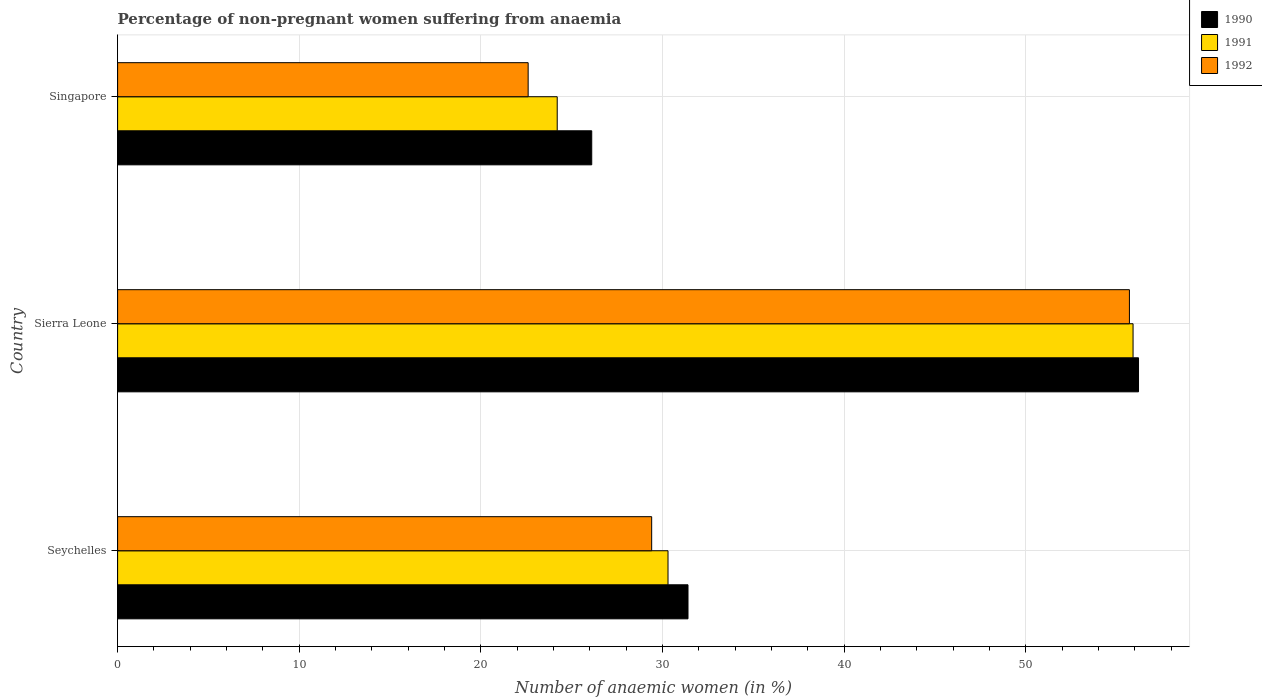How many groups of bars are there?
Offer a very short reply. 3. Are the number of bars per tick equal to the number of legend labels?
Ensure brevity in your answer.  Yes. Are the number of bars on each tick of the Y-axis equal?
Ensure brevity in your answer.  Yes. How many bars are there on the 2nd tick from the top?
Offer a very short reply. 3. How many bars are there on the 2nd tick from the bottom?
Your answer should be compact. 3. What is the label of the 2nd group of bars from the top?
Make the answer very short. Sierra Leone. What is the percentage of non-pregnant women suffering from anaemia in 1992 in Sierra Leone?
Make the answer very short. 55.7. Across all countries, what is the maximum percentage of non-pregnant women suffering from anaemia in 1990?
Your answer should be very brief. 56.2. Across all countries, what is the minimum percentage of non-pregnant women suffering from anaemia in 1991?
Provide a short and direct response. 24.2. In which country was the percentage of non-pregnant women suffering from anaemia in 1991 maximum?
Offer a very short reply. Sierra Leone. In which country was the percentage of non-pregnant women suffering from anaemia in 1990 minimum?
Offer a terse response. Singapore. What is the total percentage of non-pregnant women suffering from anaemia in 1991 in the graph?
Offer a very short reply. 110.4. What is the difference between the percentage of non-pregnant women suffering from anaemia in 1992 in Seychelles and that in Singapore?
Offer a terse response. 6.8. What is the difference between the percentage of non-pregnant women suffering from anaemia in 1990 in Sierra Leone and the percentage of non-pregnant women suffering from anaemia in 1991 in Seychelles?
Make the answer very short. 25.9. What is the average percentage of non-pregnant women suffering from anaemia in 1992 per country?
Ensure brevity in your answer.  35.9. What is the difference between the percentage of non-pregnant women suffering from anaemia in 1990 and percentage of non-pregnant women suffering from anaemia in 1991 in Seychelles?
Make the answer very short. 1.1. In how many countries, is the percentage of non-pregnant women suffering from anaemia in 1992 greater than 10 %?
Your response must be concise. 3. What is the ratio of the percentage of non-pregnant women suffering from anaemia in 1990 in Seychelles to that in Singapore?
Your response must be concise. 1.2. What is the difference between the highest and the second highest percentage of non-pregnant women suffering from anaemia in 1992?
Keep it short and to the point. 26.3. What is the difference between the highest and the lowest percentage of non-pregnant women suffering from anaemia in 1991?
Your response must be concise. 31.7. In how many countries, is the percentage of non-pregnant women suffering from anaemia in 1990 greater than the average percentage of non-pregnant women suffering from anaemia in 1990 taken over all countries?
Make the answer very short. 1. Is the sum of the percentage of non-pregnant women suffering from anaemia in 1990 in Seychelles and Sierra Leone greater than the maximum percentage of non-pregnant women suffering from anaemia in 1991 across all countries?
Ensure brevity in your answer.  Yes. Is it the case that in every country, the sum of the percentage of non-pregnant women suffering from anaemia in 1991 and percentage of non-pregnant women suffering from anaemia in 1992 is greater than the percentage of non-pregnant women suffering from anaemia in 1990?
Ensure brevity in your answer.  Yes. How many bars are there?
Your response must be concise. 9. Does the graph contain any zero values?
Ensure brevity in your answer.  No. Does the graph contain grids?
Offer a very short reply. Yes. What is the title of the graph?
Your answer should be very brief. Percentage of non-pregnant women suffering from anaemia. Does "1988" appear as one of the legend labels in the graph?
Your response must be concise. No. What is the label or title of the X-axis?
Give a very brief answer. Number of anaemic women (in %). What is the label or title of the Y-axis?
Provide a short and direct response. Country. What is the Number of anaemic women (in %) of 1990 in Seychelles?
Offer a terse response. 31.4. What is the Number of anaemic women (in %) in 1991 in Seychelles?
Offer a terse response. 30.3. What is the Number of anaemic women (in %) in 1992 in Seychelles?
Provide a short and direct response. 29.4. What is the Number of anaemic women (in %) in 1990 in Sierra Leone?
Make the answer very short. 56.2. What is the Number of anaemic women (in %) in 1991 in Sierra Leone?
Make the answer very short. 55.9. What is the Number of anaemic women (in %) of 1992 in Sierra Leone?
Offer a terse response. 55.7. What is the Number of anaemic women (in %) of 1990 in Singapore?
Give a very brief answer. 26.1. What is the Number of anaemic women (in %) in 1991 in Singapore?
Your answer should be very brief. 24.2. What is the Number of anaemic women (in %) in 1992 in Singapore?
Provide a succinct answer. 22.6. Across all countries, what is the maximum Number of anaemic women (in %) in 1990?
Your answer should be very brief. 56.2. Across all countries, what is the maximum Number of anaemic women (in %) in 1991?
Your answer should be very brief. 55.9. Across all countries, what is the maximum Number of anaemic women (in %) in 1992?
Offer a terse response. 55.7. Across all countries, what is the minimum Number of anaemic women (in %) of 1990?
Provide a short and direct response. 26.1. Across all countries, what is the minimum Number of anaemic women (in %) of 1991?
Provide a succinct answer. 24.2. Across all countries, what is the minimum Number of anaemic women (in %) in 1992?
Make the answer very short. 22.6. What is the total Number of anaemic women (in %) in 1990 in the graph?
Give a very brief answer. 113.7. What is the total Number of anaemic women (in %) in 1991 in the graph?
Ensure brevity in your answer.  110.4. What is the total Number of anaemic women (in %) in 1992 in the graph?
Keep it short and to the point. 107.7. What is the difference between the Number of anaemic women (in %) of 1990 in Seychelles and that in Sierra Leone?
Your answer should be very brief. -24.8. What is the difference between the Number of anaemic women (in %) of 1991 in Seychelles and that in Sierra Leone?
Offer a very short reply. -25.6. What is the difference between the Number of anaemic women (in %) of 1992 in Seychelles and that in Sierra Leone?
Provide a succinct answer. -26.3. What is the difference between the Number of anaemic women (in %) in 1990 in Seychelles and that in Singapore?
Provide a succinct answer. 5.3. What is the difference between the Number of anaemic women (in %) in 1990 in Sierra Leone and that in Singapore?
Your answer should be very brief. 30.1. What is the difference between the Number of anaemic women (in %) of 1991 in Sierra Leone and that in Singapore?
Ensure brevity in your answer.  31.7. What is the difference between the Number of anaemic women (in %) of 1992 in Sierra Leone and that in Singapore?
Give a very brief answer. 33.1. What is the difference between the Number of anaemic women (in %) in 1990 in Seychelles and the Number of anaemic women (in %) in 1991 in Sierra Leone?
Keep it short and to the point. -24.5. What is the difference between the Number of anaemic women (in %) of 1990 in Seychelles and the Number of anaemic women (in %) of 1992 in Sierra Leone?
Provide a short and direct response. -24.3. What is the difference between the Number of anaemic women (in %) of 1991 in Seychelles and the Number of anaemic women (in %) of 1992 in Sierra Leone?
Offer a terse response. -25.4. What is the difference between the Number of anaemic women (in %) in 1990 in Seychelles and the Number of anaemic women (in %) in 1992 in Singapore?
Your answer should be compact. 8.8. What is the difference between the Number of anaemic women (in %) in 1991 in Seychelles and the Number of anaemic women (in %) in 1992 in Singapore?
Give a very brief answer. 7.7. What is the difference between the Number of anaemic women (in %) in 1990 in Sierra Leone and the Number of anaemic women (in %) in 1992 in Singapore?
Offer a very short reply. 33.6. What is the difference between the Number of anaemic women (in %) of 1991 in Sierra Leone and the Number of anaemic women (in %) of 1992 in Singapore?
Keep it short and to the point. 33.3. What is the average Number of anaemic women (in %) in 1990 per country?
Provide a short and direct response. 37.9. What is the average Number of anaemic women (in %) in 1991 per country?
Offer a very short reply. 36.8. What is the average Number of anaemic women (in %) in 1992 per country?
Provide a succinct answer. 35.9. What is the difference between the Number of anaemic women (in %) of 1990 and Number of anaemic women (in %) of 1991 in Seychelles?
Offer a very short reply. 1.1. What is the difference between the Number of anaemic women (in %) of 1991 and Number of anaemic women (in %) of 1992 in Seychelles?
Offer a terse response. 0.9. What is the difference between the Number of anaemic women (in %) in 1990 and Number of anaemic women (in %) in 1992 in Sierra Leone?
Offer a very short reply. 0.5. What is the difference between the Number of anaemic women (in %) of 1991 and Number of anaemic women (in %) of 1992 in Sierra Leone?
Your answer should be compact. 0.2. What is the ratio of the Number of anaemic women (in %) in 1990 in Seychelles to that in Sierra Leone?
Provide a succinct answer. 0.56. What is the ratio of the Number of anaemic women (in %) in 1991 in Seychelles to that in Sierra Leone?
Your response must be concise. 0.54. What is the ratio of the Number of anaemic women (in %) in 1992 in Seychelles to that in Sierra Leone?
Ensure brevity in your answer.  0.53. What is the ratio of the Number of anaemic women (in %) in 1990 in Seychelles to that in Singapore?
Your answer should be compact. 1.2. What is the ratio of the Number of anaemic women (in %) in 1991 in Seychelles to that in Singapore?
Provide a short and direct response. 1.25. What is the ratio of the Number of anaemic women (in %) of 1992 in Seychelles to that in Singapore?
Make the answer very short. 1.3. What is the ratio of the Number of anaemic women (in %) in 1990 in Sierra Leone to that in Singapore?
Your answer should be very brief. 2.15. What is the ratio of the Number of anaemic women (in %) in 1991 in Sierra Leone to that in Singapore?
Offer a terse response. 2.31. What is the ratio of the Number of anaemic women (in %) in 1992 in Sierra Leone to that in Singapore?
Offer a terse response. 2.46. What is the difference between the highest and the second highest Number of anaemic women (in %) in 1990?
Provide a short and direct response. 24.8. What is the difference between the highest and the second highest Number of anaemic women (in %) of 1991?
Your answer should be compact. 25.6. What is the difference between the highest and the second highest Number of anaemic women (in %) in 1992?
Keep it short and to the point. 26.3. What is the difference between the highest and the lowest Number of anaemic women (in %) of 1990?
Your response must be concise. 30.1. What is the difference between the highest and the lowest Number of anaemic women (in %) in 1991?
Provide a succinct answer. 31.7. What is the difference between the highest and the lowest Number of anaemic women (in %) in 1992?
Your answer should be very brief. 33.1. 